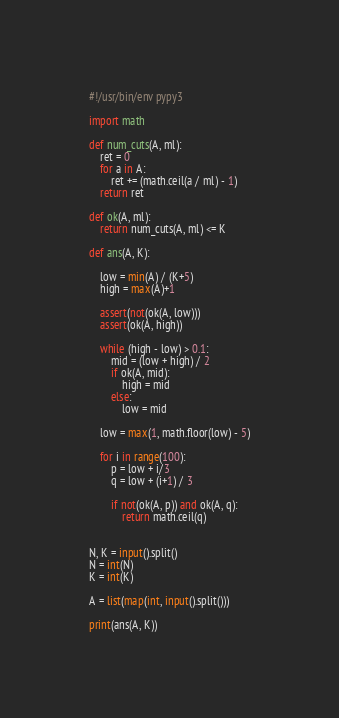<code> <loc_0><loc_0><loc_500><loc_500><_Python_>#!/usr/bin/env pypy3

import math

def num_cuts(A, ml):
	ret = 0
	for a in A:
		ret += (math.ceil(a / ml) - 1)
	return ret

def ok(A, ml):
	return num_cuts(A, ml) <= K

def ans(A, K):

	low = min(A) / (K+5)
	high = max(A)+1

	assert(not(ok(A, low)))
	assert(ok(A, high))

	while (high - low) > 0.1:
		mid = (low + high) / 2
		if ok(A, mid):
			high = mid
		else:
			low = mid

	low = max(1, math.floor(low) - 5)

	for i in range(100):
		p = low + i/3
		q = low + (i+1) / 3

		if not(ok(A, p)) and ok(A, q):
			return math.ceil(q)


N, K = input().split()
N = int(N)
K = int(K)

A = list(map(int, input().split()))

print(ans(A, K))</code> 